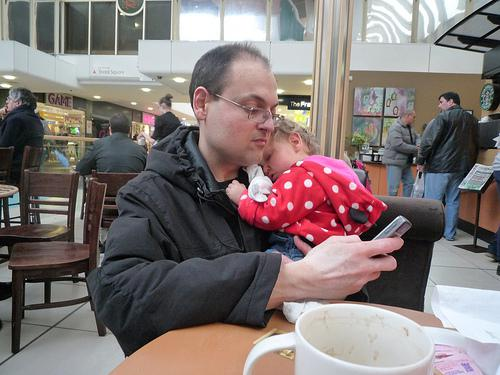Question: what is he doing?
Choices:
A. On the phone.
B. Playing baseball.
C. Building a home.
D. Singing.
Answer with the letter. Answer: A Question: where is this scene?
Choices:
A. Supermarket.
B. Food court.
C. Butcher shop.
D. Bakery.
Answer with the letter. Answer: B Question: what is he holding?
Choices:
A. Clipboard.
B. Whistle.
C. Stop watch.
D. Phone.
Answer with the letter. Answer: D Question: why is he on the phone?
Choices:
A. Listening to messages.
B. Calling his famly.
C. Working.
D. Communication.
Answer with the letter. Answer: D Question: how is the photo?
Choices:
A. Blurry.
B. Dark.
C. Clear.
D. Faded.
Answer with the letter. Answer: C Question: what color is the table?
Choices:
A. White.
B. Black.
C. Blue.
D. Brown.
Answer with the letter. Answer: D 